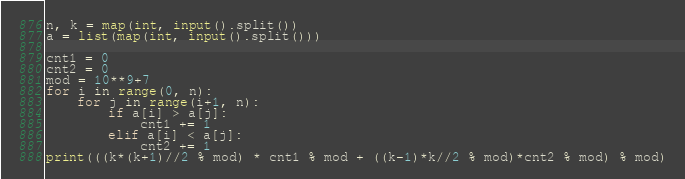Convert code to text. <code><loc_0><loc_0><loc_500><loc_500><_Python_>n, k = map(int, input().split())
a = list(map(int, input().split()))

cnt1 = 0
cnt2 = 0
mod = 10**9+7
for i in range(0, n):
    for j in range(i+1, n):
        if a[i] > a[j]:
            cnt1 += 1
        elif a[i] < a[j]:
            cnt2 += 1
print(((k*(k+1)//2 % mod) * cnt1 % mod + ((k-1)*k//2 % mod)*cnt2 % mod) % mod)
</code> 